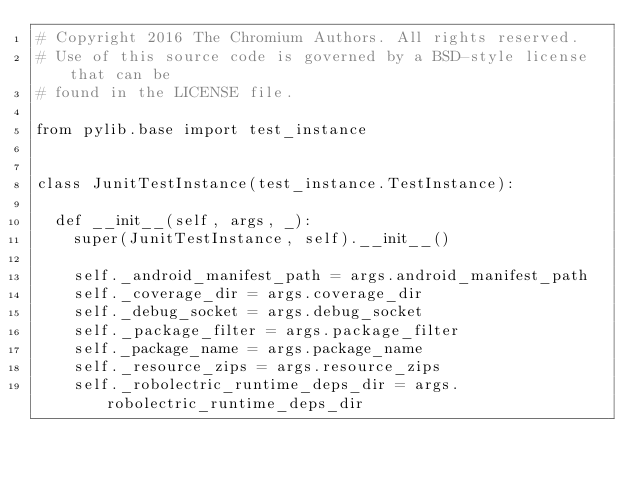Convert code to text. <code><loc_0><loc_0><loc_500><loc_500><_Python_># Copyright 2016 The Chromium Authors. All rights reserved.
# Use of this source code is governed by a BSD-style license that can be
# found in the LICENSE file.

from pylib.base import test_instance


class JunitTestInstance(test_instance.TestInstance):

  def __init__(self, args, _):
    super(JunitTestInstance, self).__init__()

    self._android_manifest_path = args.android_manifest_path
    self._coverage_dir = args.coverage_dir
    self._debug_socket = args.debug_socket
    self._package_filter = args.package_filter
    self._package_name = args.package_name
    self._resource_zips = args.resource_zips
    self._robolectric_runtime_deps_dir = args.robolectric_runtime_deps_dir</code> 